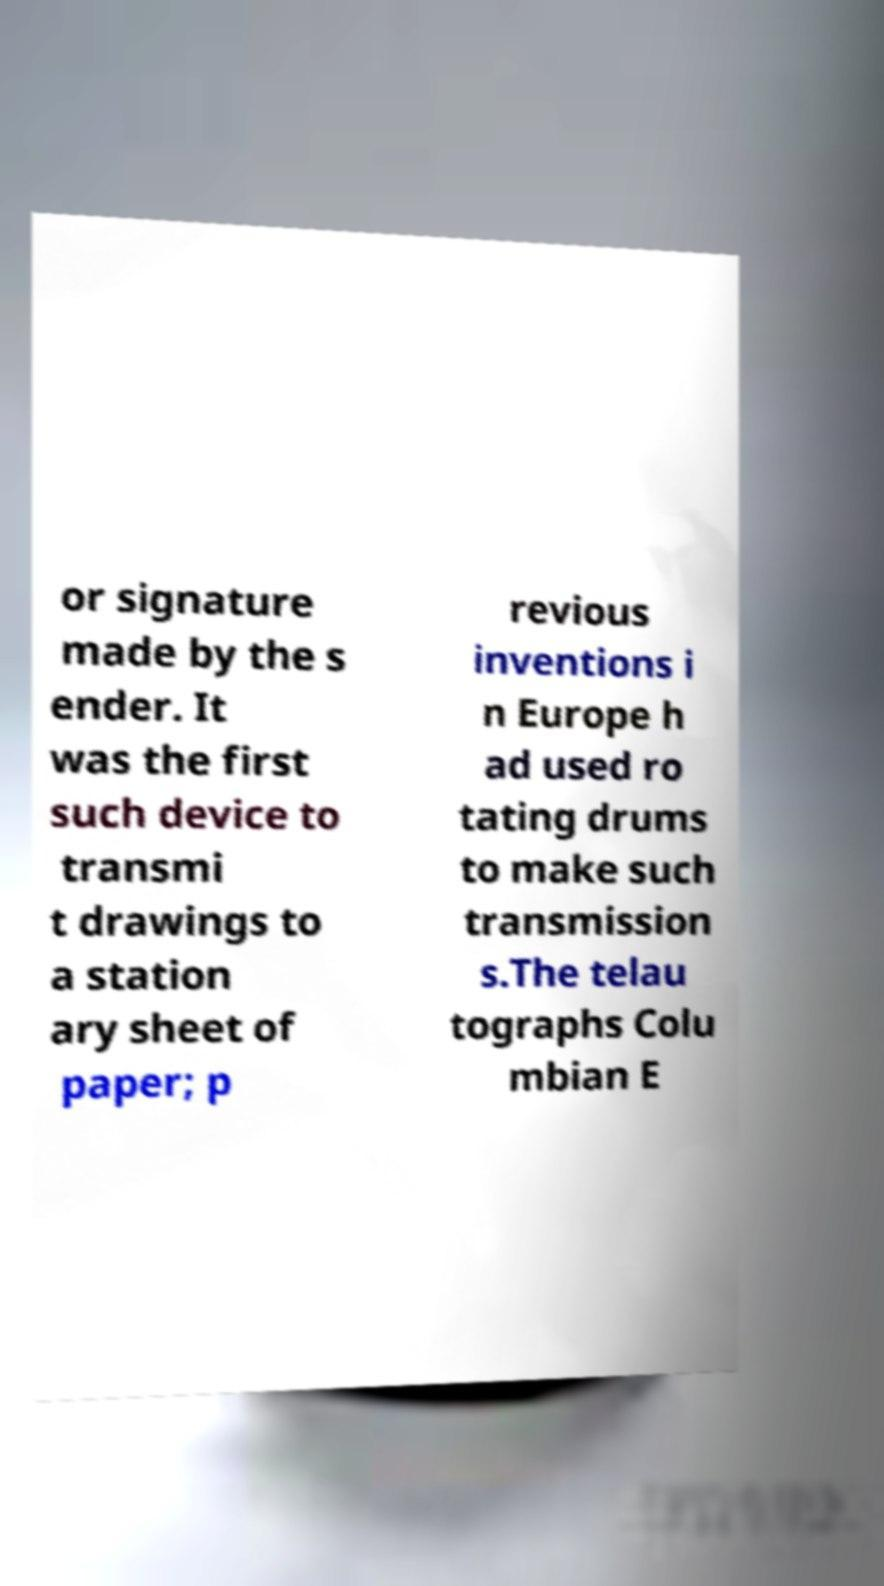Please identify and transcribe the text found in this image. or signature made by the s ender. It was the first such device to transmi t drawings to a station ary sheet of paper; p revious inventions i n Europe h ad used ro tating drums to make such transmission s.The telau tographs Colu mbian E 